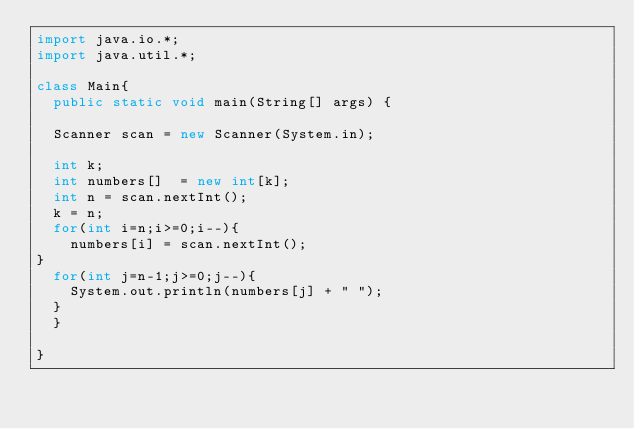<code> <loc_0><loc_0><loc_500><loc_500><_Java_>import java.io.*;
import java.util.*;

class Main{
  public static void main(String[] args) {

  Scanner scan = new Scanner(System.in);

  int k;
  int numbers[]  = new int[k];
  int n = scan.nextInt();
  k = n;
  for(int i=n;i>=0;i--){
    numbers[i] = scan.nextInt();
}
  for(int j=n-1;j>=0;j--){
    System.out.println(numbers[j] + " ");
  }
  }

}</code> 